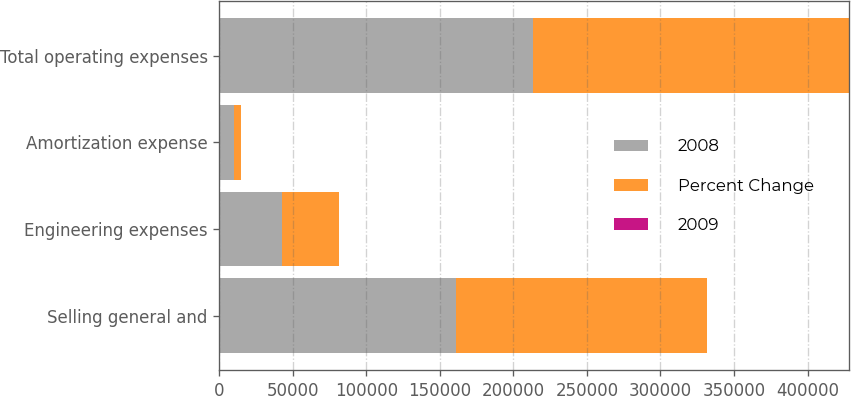Convert chart to OTSL. <chart><loc_0><loc_0><loc_500><loc_500><stacked_bar_chart><ecel><fcel>Selling general and<fcel>Engineering expenses<fcel>Amortization expense<fcel>Total operating expenses<nl><fcel>2008<fcel>160998<fcel>42447<fcel>9849<fcel>213294<nl><fcel>Percent Change<fcel>170597<fcel>38981<fcel>5092<fcel>214670<nl><fcel>2009<fcel>5.6<fcel>8.9<fcel>93.4<fcel>0.6<nl></chart> 